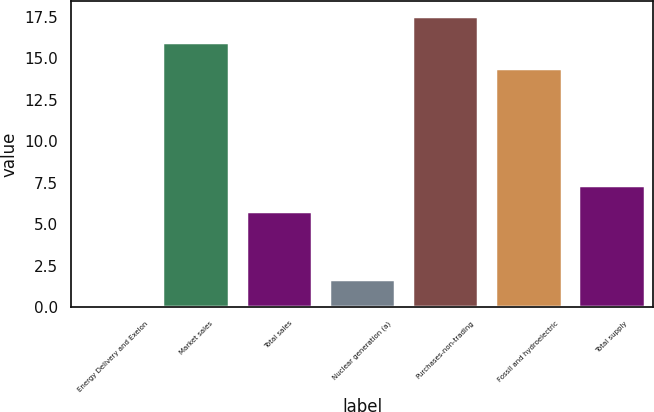Convert chart to OTSL. <chart><loc_0><loc_0><loc_500><loc_500><bar_chart><fcel>Energy Delivery and Exelon<fcel>Market sales<fcel>Total sales<fcel>Nuclear generation (a)<fcel>Purchases-non-trading<fcel>Fossil and hydroelectric<fcel>Total supply<nl><fcel>0.1<fcel>15.97<fcel>5.8<fcel>1.67<fcel>17.54<fcel>14.4<fcel>7.37<nl></chart> 